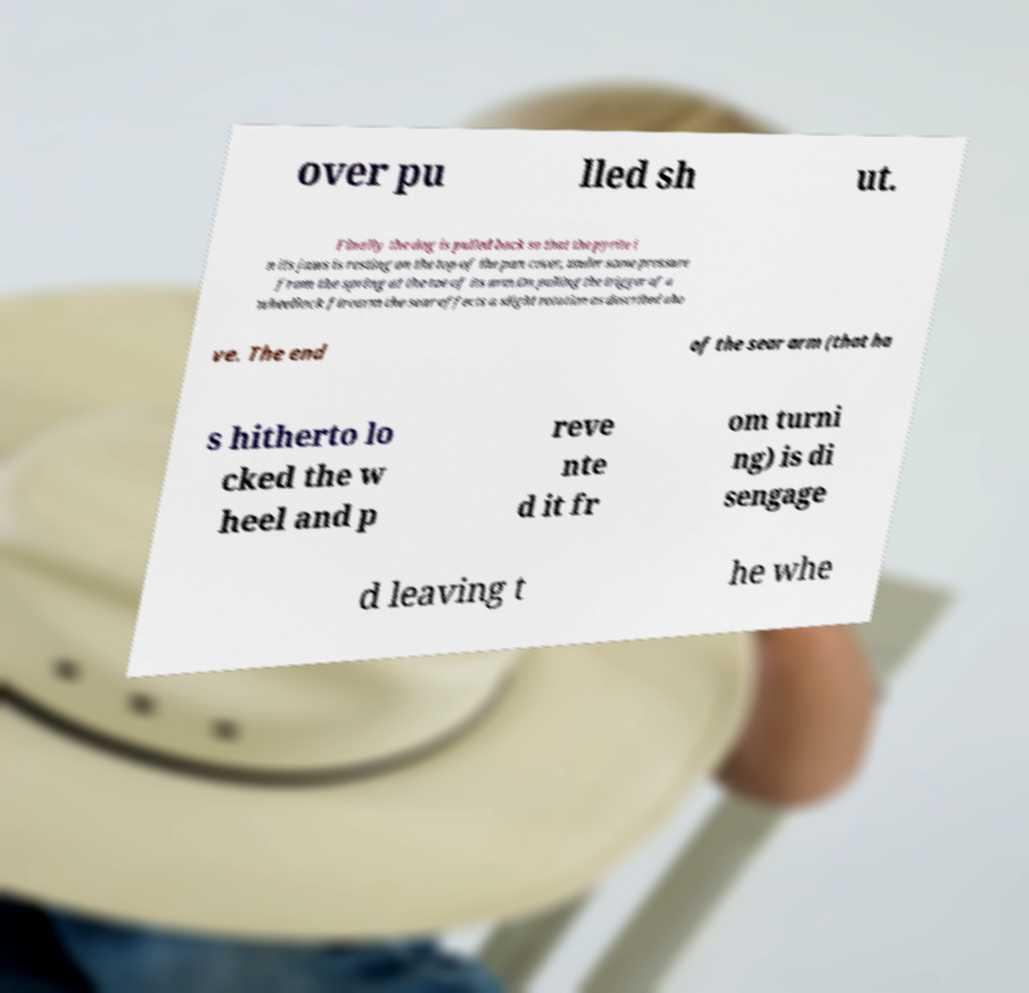Can you accurately transcribe the text from the provided image for me? over pu lled sh ut. Finally the dog is pulled back so that the pyrite i n its jaws is resting on the top of the pan cover, under some pressure from the spring at the toe of its arm.On pulling the trigger of a wheellock firearm the sear effects a slight rotation as described abo ve. The end of the sear arm (that ha s hitherto lo cked the w heel and p reve nte d it fr om turni ng) is di sengage d leaving t he whe 